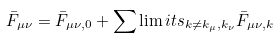Convert formula to latex. <formula><loc_0><loc_0><loc_500><loc_500>\bar { F } _ { \mu \nu } = \bar { F } _ { \mu \nu , 0 } + \sum \lim i t s _ { k \neq k _ { \mu } , k _ { \nu } } \bar { F } _ { \mu \nu , k }</formula> 